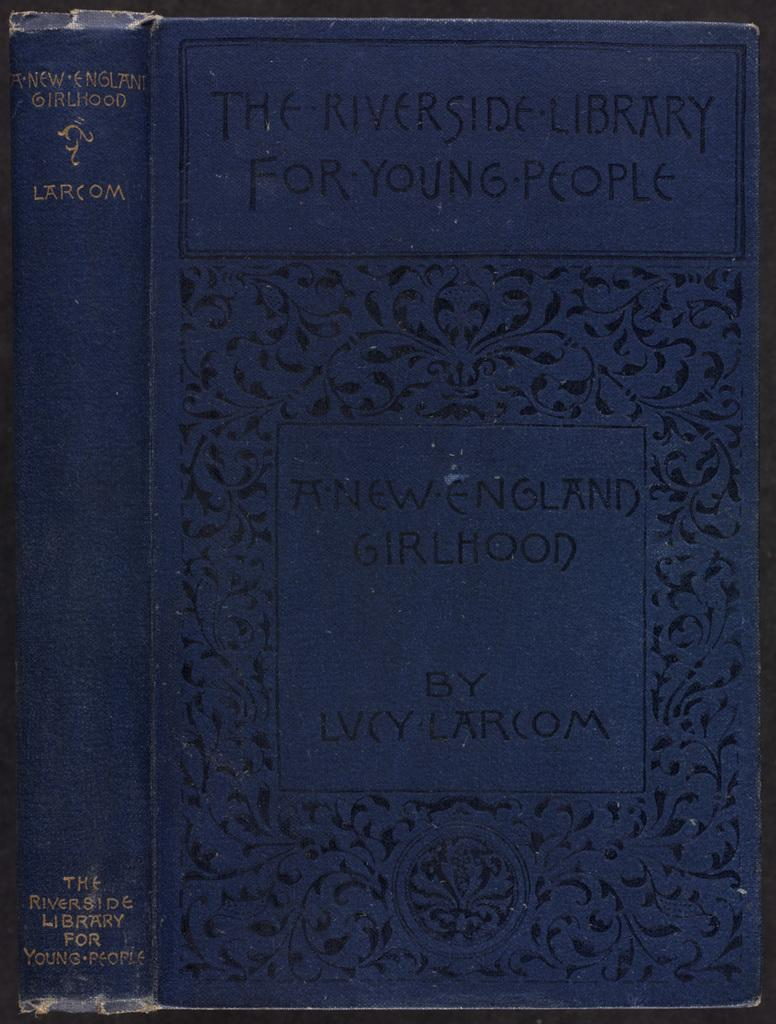Provide a one-sentence caption for the provided image. A copy of New England Girlhood by Lucy Larcom is at the Riverside Library for Young People. 